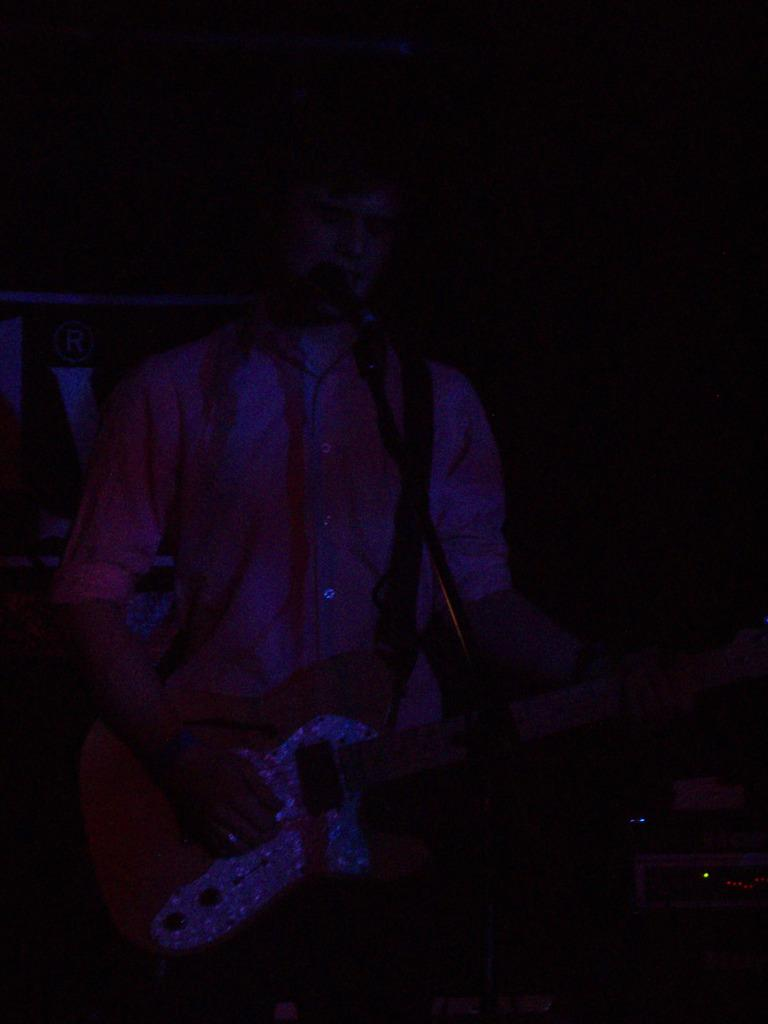What is the man in the image doing? The man is playing a guitar in the image. What object is present that is typically used for amplifying sound? There is a microphone in the image. What color is the background of the image? The background of the image is black. Can you see any vases in the image? There is no vase present in the image. Does the man in the image express any regret while playing the guitar? The image does not provide any information about the man's emotions or feelings, so it cannot be determined if he expresses regret. 